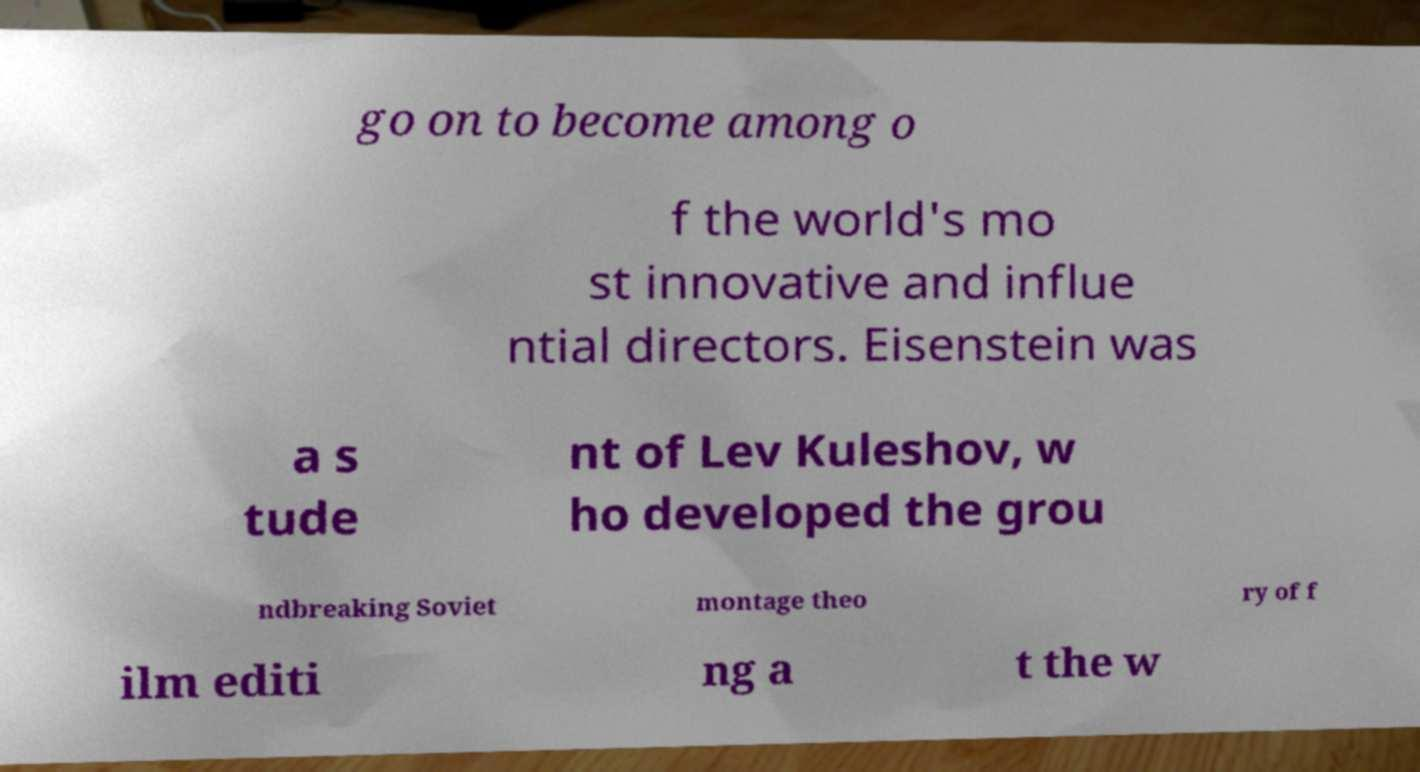Could you assist in decoding the text presented in this image and type it out clearly? go on to become among o f the world's mo st innovative and influe ntial directors. Eisenstein was a s tude nt of Lev Kuleshov, w ho developed the grou ndbreaking Soviet montage theo ry of f ilm editi ng a t the w 